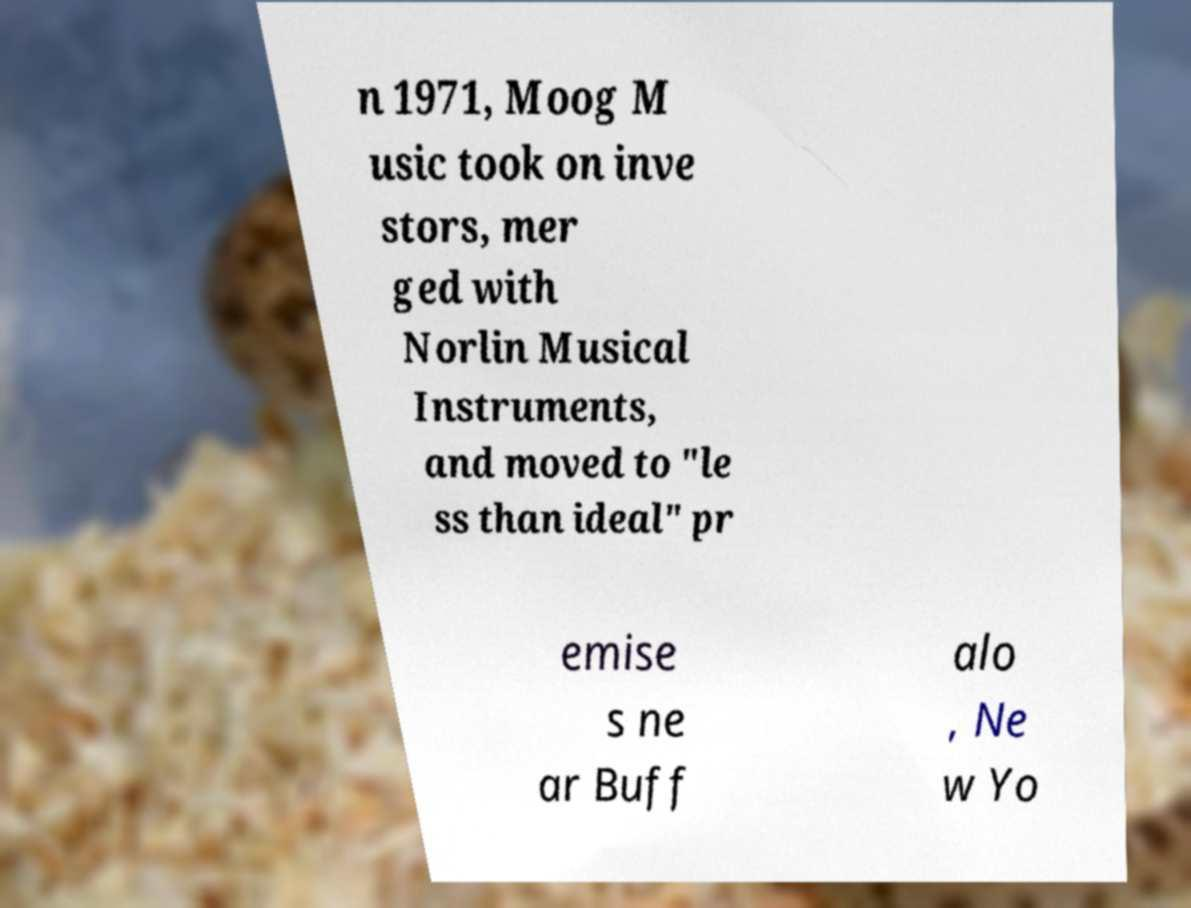There's text embedded in this image that I need extracted. Can you transcribe it verbatim? n 1971, Moog M usic took on inve stors, mer ged with Norlin Musical Instruments, and moved to "le ss than ideal" pr emise s ne ar Buff alo , Ne w Yo 